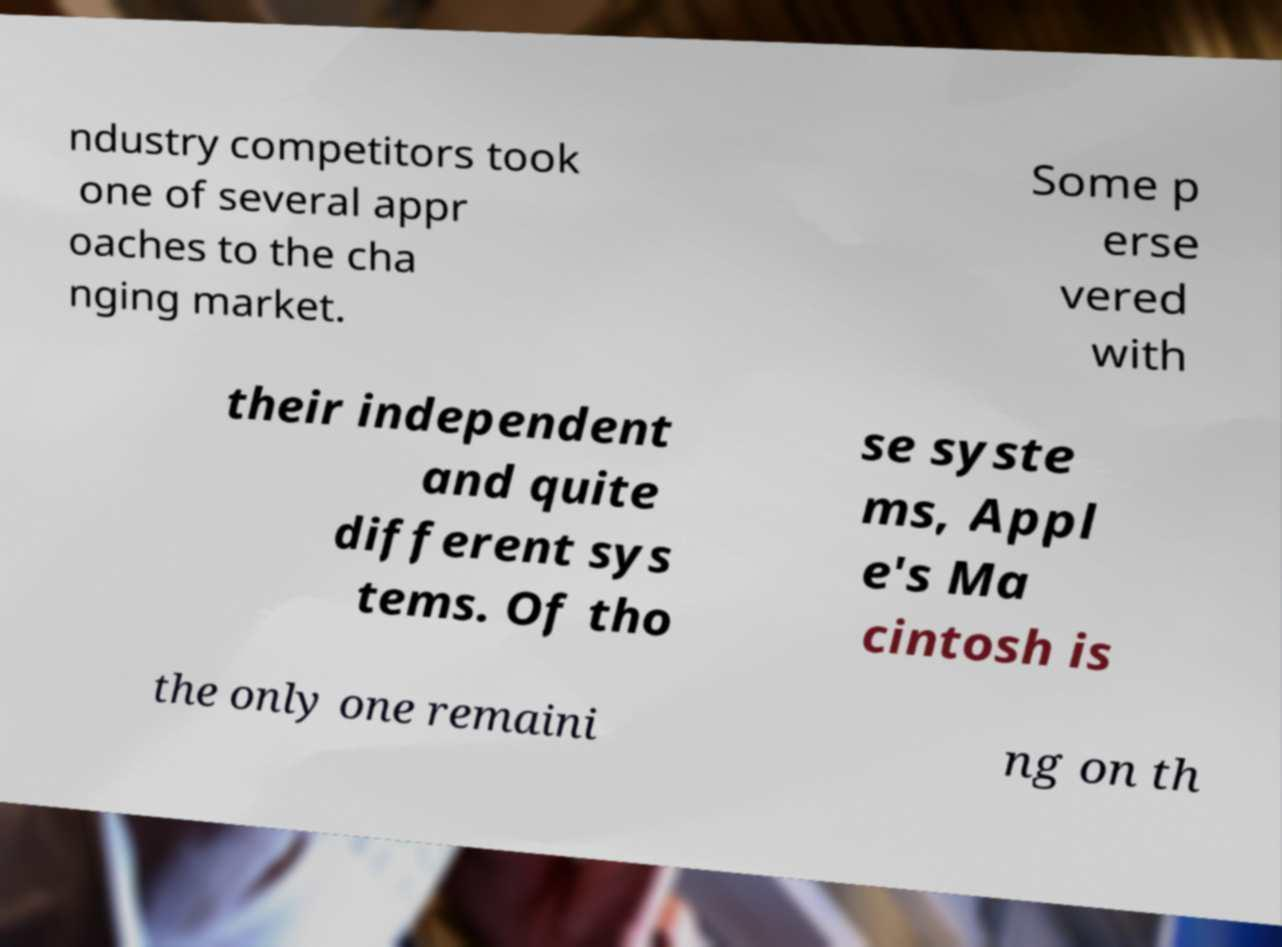Please identify and transcribe the text found in this image. ndustry competitors took one of several appr oaches to the cha nging market. Some p erse vered with their independent and quite different sys tems. Of tho se syste ms, Appl e's Ma cintosh is the only one remaini ng on th 